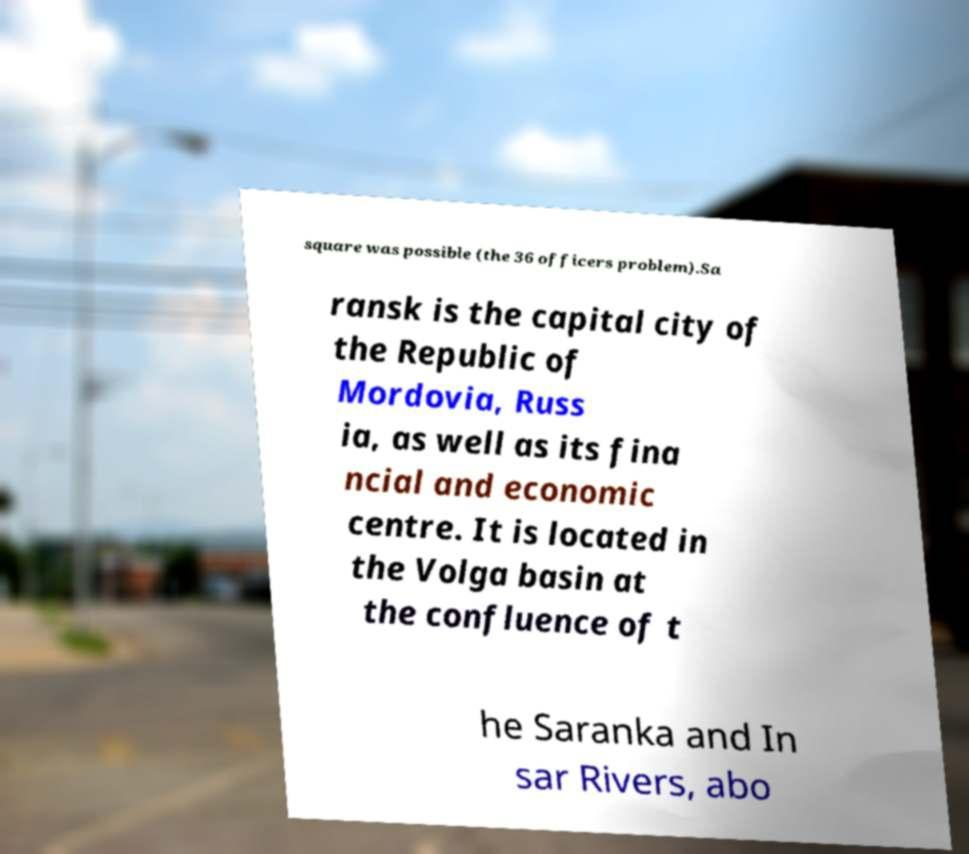Can you read and provide the text displayed in the image?This photo seems to have some interesting text. Can you extract and type it out for me? square was possible (the 36 officers problem).Sa ransk is the capital city of the Republic of Mordovia, Russ ia, as well as its fina ncial and economic centre. It is located in the Volga basin at the confluence of t he Saranka and In sar Rivers, abo 